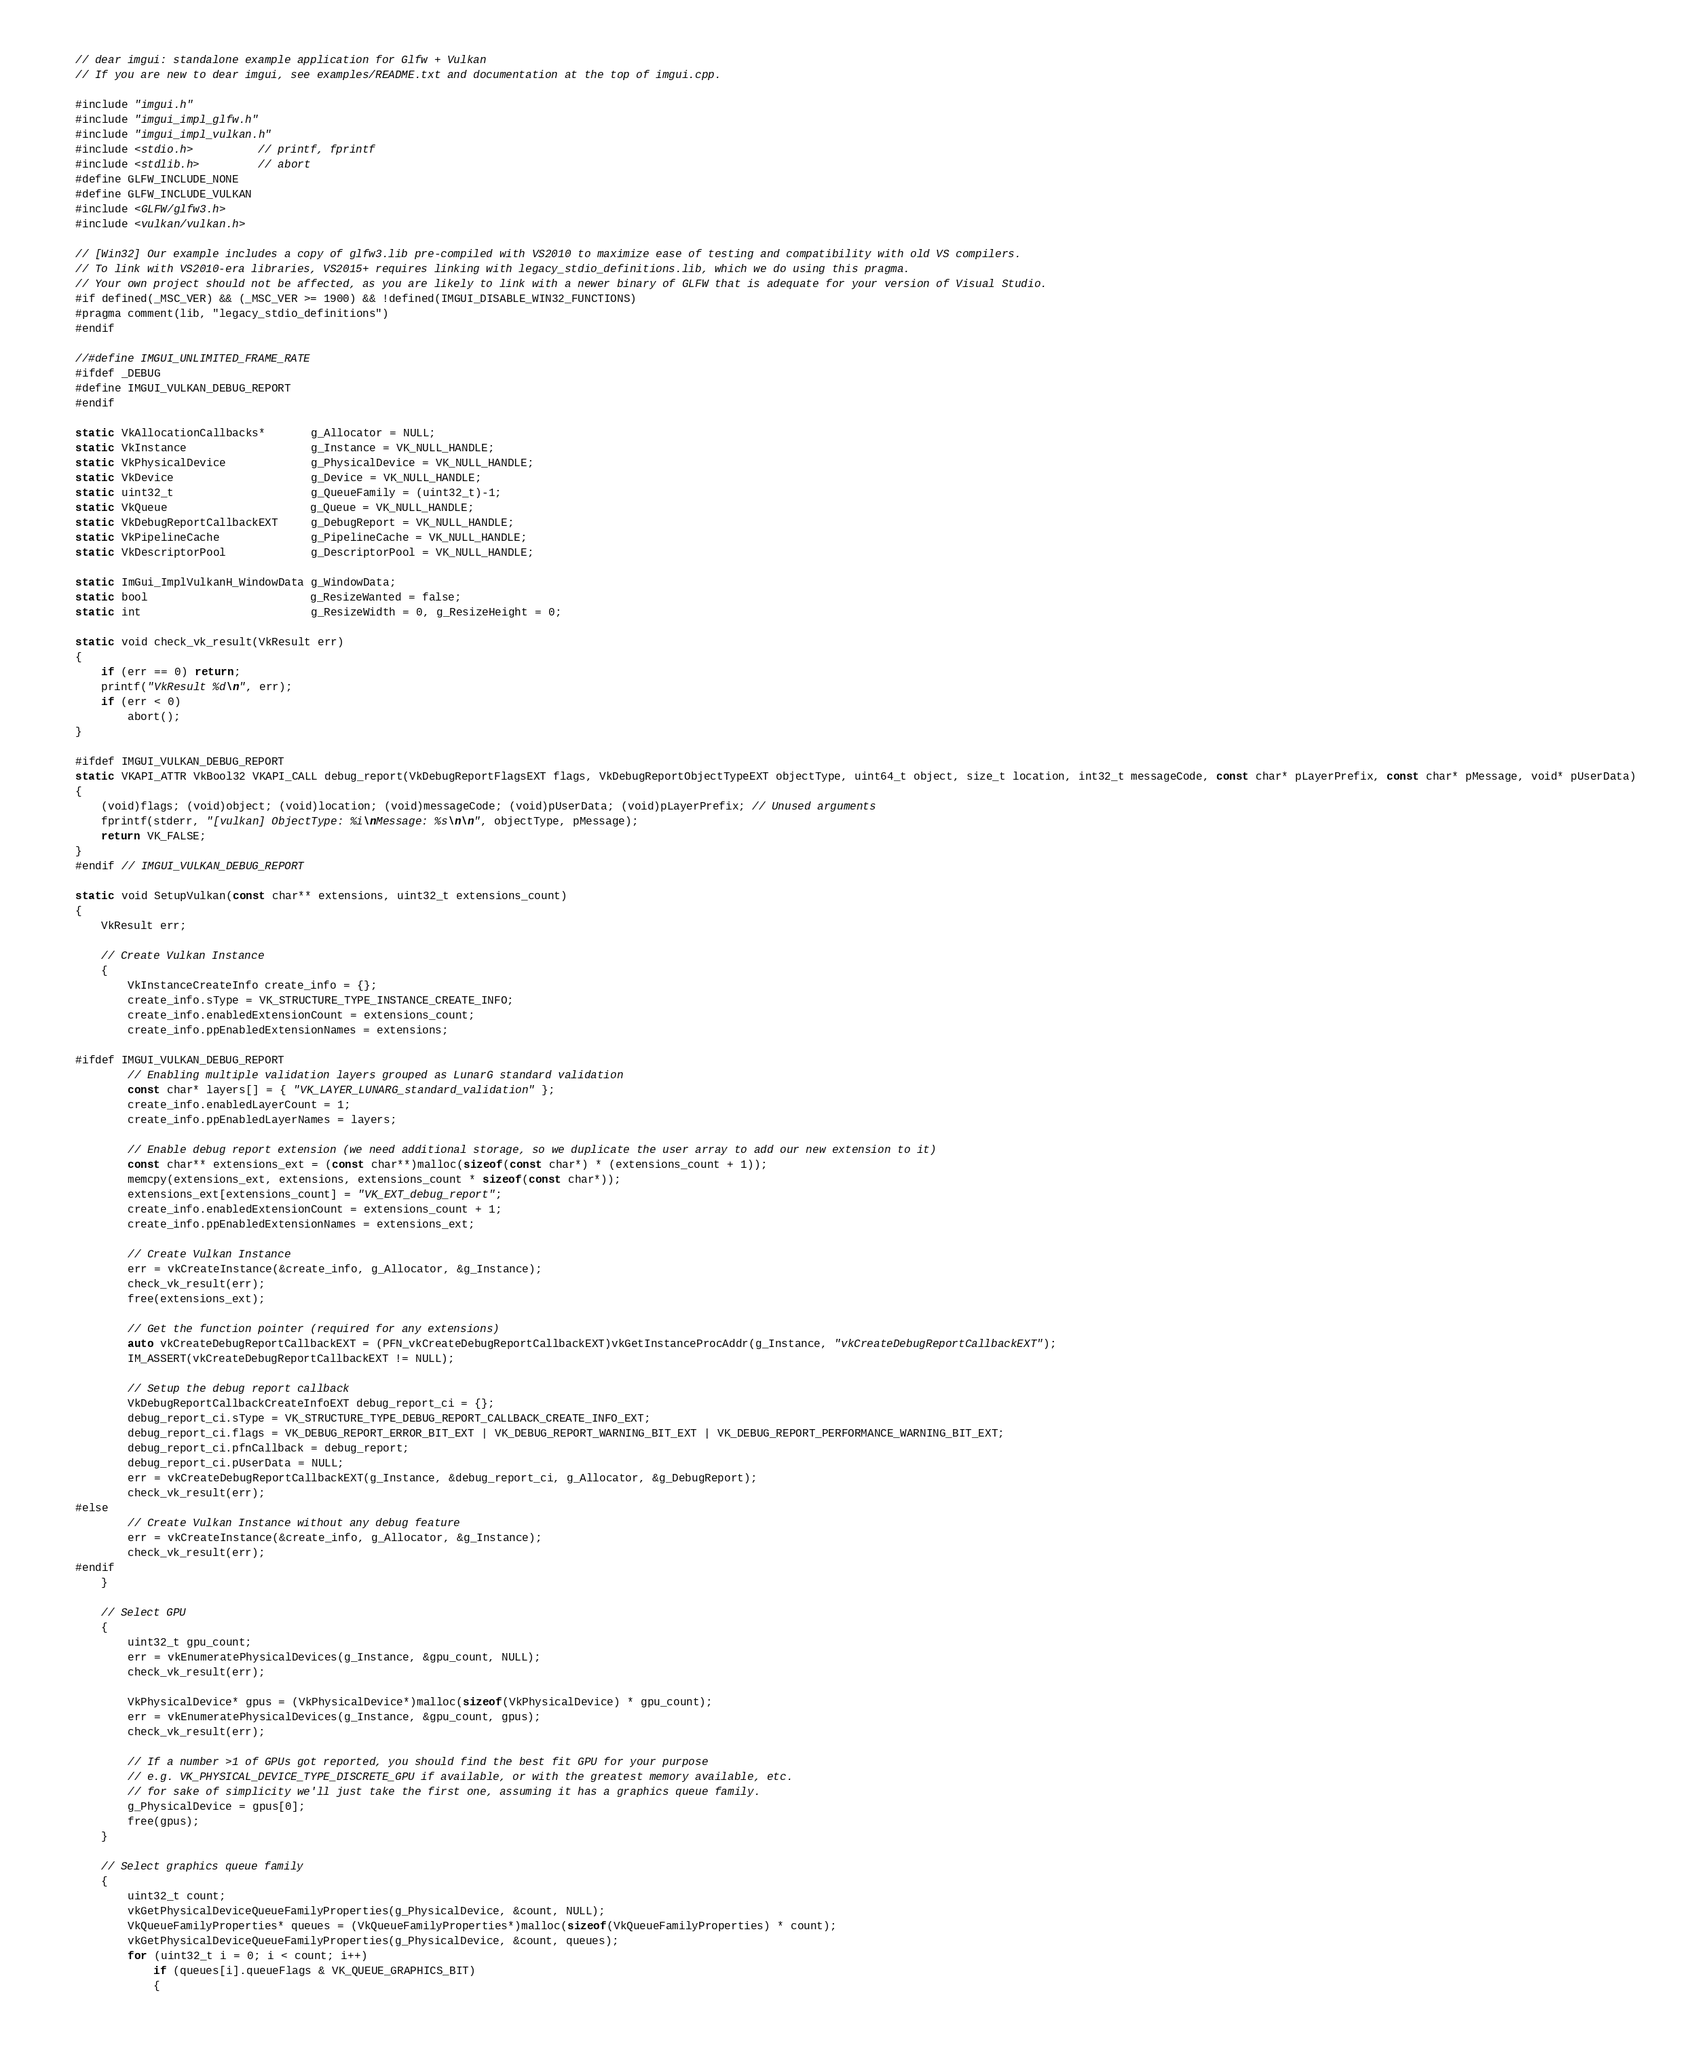<code> <loc_0><loc_0><loc_500><loc_500><_C++_>// dear imgui: standalone example application for Glfw + Vulkan
// If you are new to dear imgui, see examples/README.txt and documentation at the top of imgui.cpp.

#include "imgui.h"
#include "imgui_impl_glfw.h"
#include "imgui_impl_vulkan.h"
#include <stdio.h>          // printf, fprintf
#include <stdlib.h>         // abort
#define GLFW_INCLUDE_NONE
#define GLFW_INCLUDE_VULKAN
#include <GLFW/glfw3.h>
#include <vulkan/vulkan.h>

// [Win32] Our example includes a copy of glfw3.lib pre-compiled with VS2010 to maximize ease of testing and compatibility with old VS compilers.
// To link with VS2010-era libraries, VS2015+ requires linking with legacy_stdio_definitions.lib, which we do using this pragma.
// Your own project should not be affected, as you are likely to link with a newer binary of GLFW that is adequate for your version of Visual Studio.
#if defined(_MSC_VER) && (_MSC_VER >= 1900) && !defined(IMGUI_DISABLE_WIN32_FUNCTIONS)
#pragma comment(lib, "legacy_stdio_definitions")
#endif

//#define IMGUI_UNLIMITED_FRAME_RATE
#ifdef _DEBUG
#define IMGUI_VULKAN_DEBUG_REPORT
#endif

static VkAllocationCallbacks*       g_Allocator = NULL;
static VkInstance                   g_Instance = VK_NULL_HANDLE;
static VkPhysicalDevice             g_PhysicalDevice = VK_NULL_HANDLE;
static VkDevice                     g_Device = VK_NULL_HANDLE;
static uint32_t                     g_QueueFamily = (uint32_t)-1;
static VkQueue                      g_Queue = VK_NULL_HANDLE;
static VkDebugReportCallbackEXT     g_DebugReport = VK_NULL_HANDLE;
static VkPipelineCache              g_PipelineCache = VK_NULL_HANDLE;
static VkDescriptorPool             g_DescriptorPool = VK_NULL_HANDLE;

static ImGui_ImplVulkanH_WindowData g_WindowData;
static bool                         g_ResizeWanted = false;
static int                          g_ResizeWidth = 0, g_ResizeHeight = 0;

static void check_vk_result(VkResult err)
{
    if (err == 0) return;
    printf("VkResult %d\n", err);
    if (err < 0)
        abort();
}

#ifdef IMGUI_VULKAN_DEBUG_REPORT
static VKAPI_ATTR VkBool32 VKAPI_CALL debug_report(VkDebugReportFlagsEXT flags, VkDebugReportObjectTypeEXT objectType, uint64_t object, size_t location, int32_t messageCode, const char* pLayerPrefix, const char* pMessage, void* pUserData)
{
    (void)flags; (void)object; (void)location; (void)messageCode; (void)pUserData; (void)pLayerPrefix; // Unused arguments
    fprintf(stderr, "[vulkan] ObjectType: %i\nMessage: %s\n\n", objectType, pMessage);
    return VK_FALSE;
}
#endif // IMGUI_VULKAN_DEBUG_REPORT

static void SetupVulkan(const char** extensions, uint32_t extensions_count)
{
    VkResult err;

    // Create Vulkan Instance
    {
        VkInstanceCreateInfo create_info = {};
        create_info.sType = VK_STRUCTURE_TYPE_INSTANCE_CREATE_INFO;
        create_info.enabledExtensionCount = extensions_count;
        create_info.ppEnabledExtensionNames = extensions;

#ifdef IMGUI_VULKAN_DEBUG_REPORT
        // Enabling multiple validation layers grouped as LunarG standard validation
        const char* layers[] = { "VK_LAYER_LUNARG_standard_validation" };
        create_info.enabledLayerCount = 1;
        create_info.ppEnabledLayerNames = layers;

        // Enable debug report extension (we need additional storage, so we duplicate the user array to add our new extension to it)
        const char** extensions_ext = (const char**)malloc(sizeof(const char*) * (extensions_count + 1));
        memcpy(extensions_ext, extensions, extensions_count * sizeof(const char*));
        extensions_ext[extensions_count] = "VK_EXT_debug_report";
        create_info.enabledExtensionCount = extensions_count + 1;
        create_info.ppEnabledExtensionNames = extensions_ext;

        // Create Vulkan Instance
        err = vkCreateInstance(&create_info, g_Allocator, &g_Instance);
        check_vk_result(err);
        free(extensions_ext);

        // Get the function pointer (required for any extensions)
        auto vkCreateDebugReportCallbackEXT = (PFN_vkCreateDebugReportCallbackEXT)vkGetInstanceProcAddr(g_Instance, "vkCreateDebugReportCallbackEXT");
        IM_ASSERT(vkCreateDebugReportCallbackEXT != NULL);

        // Setup the debug report callback
        VkDebugReportCallbackCreateInfoEXT debug_report_ci = {};
        debug_report_ci.sType = VK_STRUCTURE_TYPE_DEBUG_REPORT_CALLBACK_CREATE_INFO_EXT;
        debug_report_ci.flags = VK_DEBUG_REPORT_ERROR_BIT_EXT | VK_DEBUG_REPORT_WARNING_BIT_EXT | VK_DEBUG_REPORT_PERFORMANCE_WARNING_BIT_EXT;
        debug_report_ci.pfnCallback = debug_report;
        debug_report_ci.pUserData = NULL;
        err = vkCreateDebugReportCallbackEXT(g_Instance, &debug_report_ci, g_Allocator, &g_DebugReport);
        check_vk_result(err);
#else
        // Create Vulkan Instance without any debug feature
        err = vkCreateInstance(&create_info, g_Allocator, &g_Instance);
        check_vk_result(err);
#endif
    }

    // Select GPU
    {
        uint32_t gpu_count;
        err = vkEnumeratePhysicalDevices(g_Instance, &gpu_count, NULL);
        check_vk_result(err);

        VkPhysicalDevice* gpus = (VkPhysicalDevice*)malloc(sizeof(VkPhysicalDevice) * gpu_count);
        err = vkEnumeratePhysicalDevices(g_Instance, &gpu_count, gpus);
        check_vk_result(err);

        // If a number >1 of GPUs got reported, you should find the best fit GPU for your purpose
        // e.g. VK_PHYSICAL_DEVICE_TYPE_DISCRETE_GPU if available, or with the greatest memory available, etc.
        // for sake of simplicity we'll just take the first one, assuming it has a graphics queue family.
        g_PhysicalDevice = gpus[0];
        free(gpus);
    }

    // Select graphics queue family
    {
        uint32_t count;
        vkGetPhysicalDeviceQueueFamilyProperties(g_PhysicalDevice, &count, NULL);
        VkQueueFamilyProperties* queues = (VkQueueFamilyProperties*)malloc(sizeof(VkQueueFamilyProperties) * count);
        vkGetPhysicalDeviceQueueFamilyProperties(g_PhysicalDevice, &count, queues);
        for (uint32_t i = 0; i < count; i++)
            if (queues[i].queueFlags & VK_QUEUE_GRAPHICS_BIT)
            {</code> 